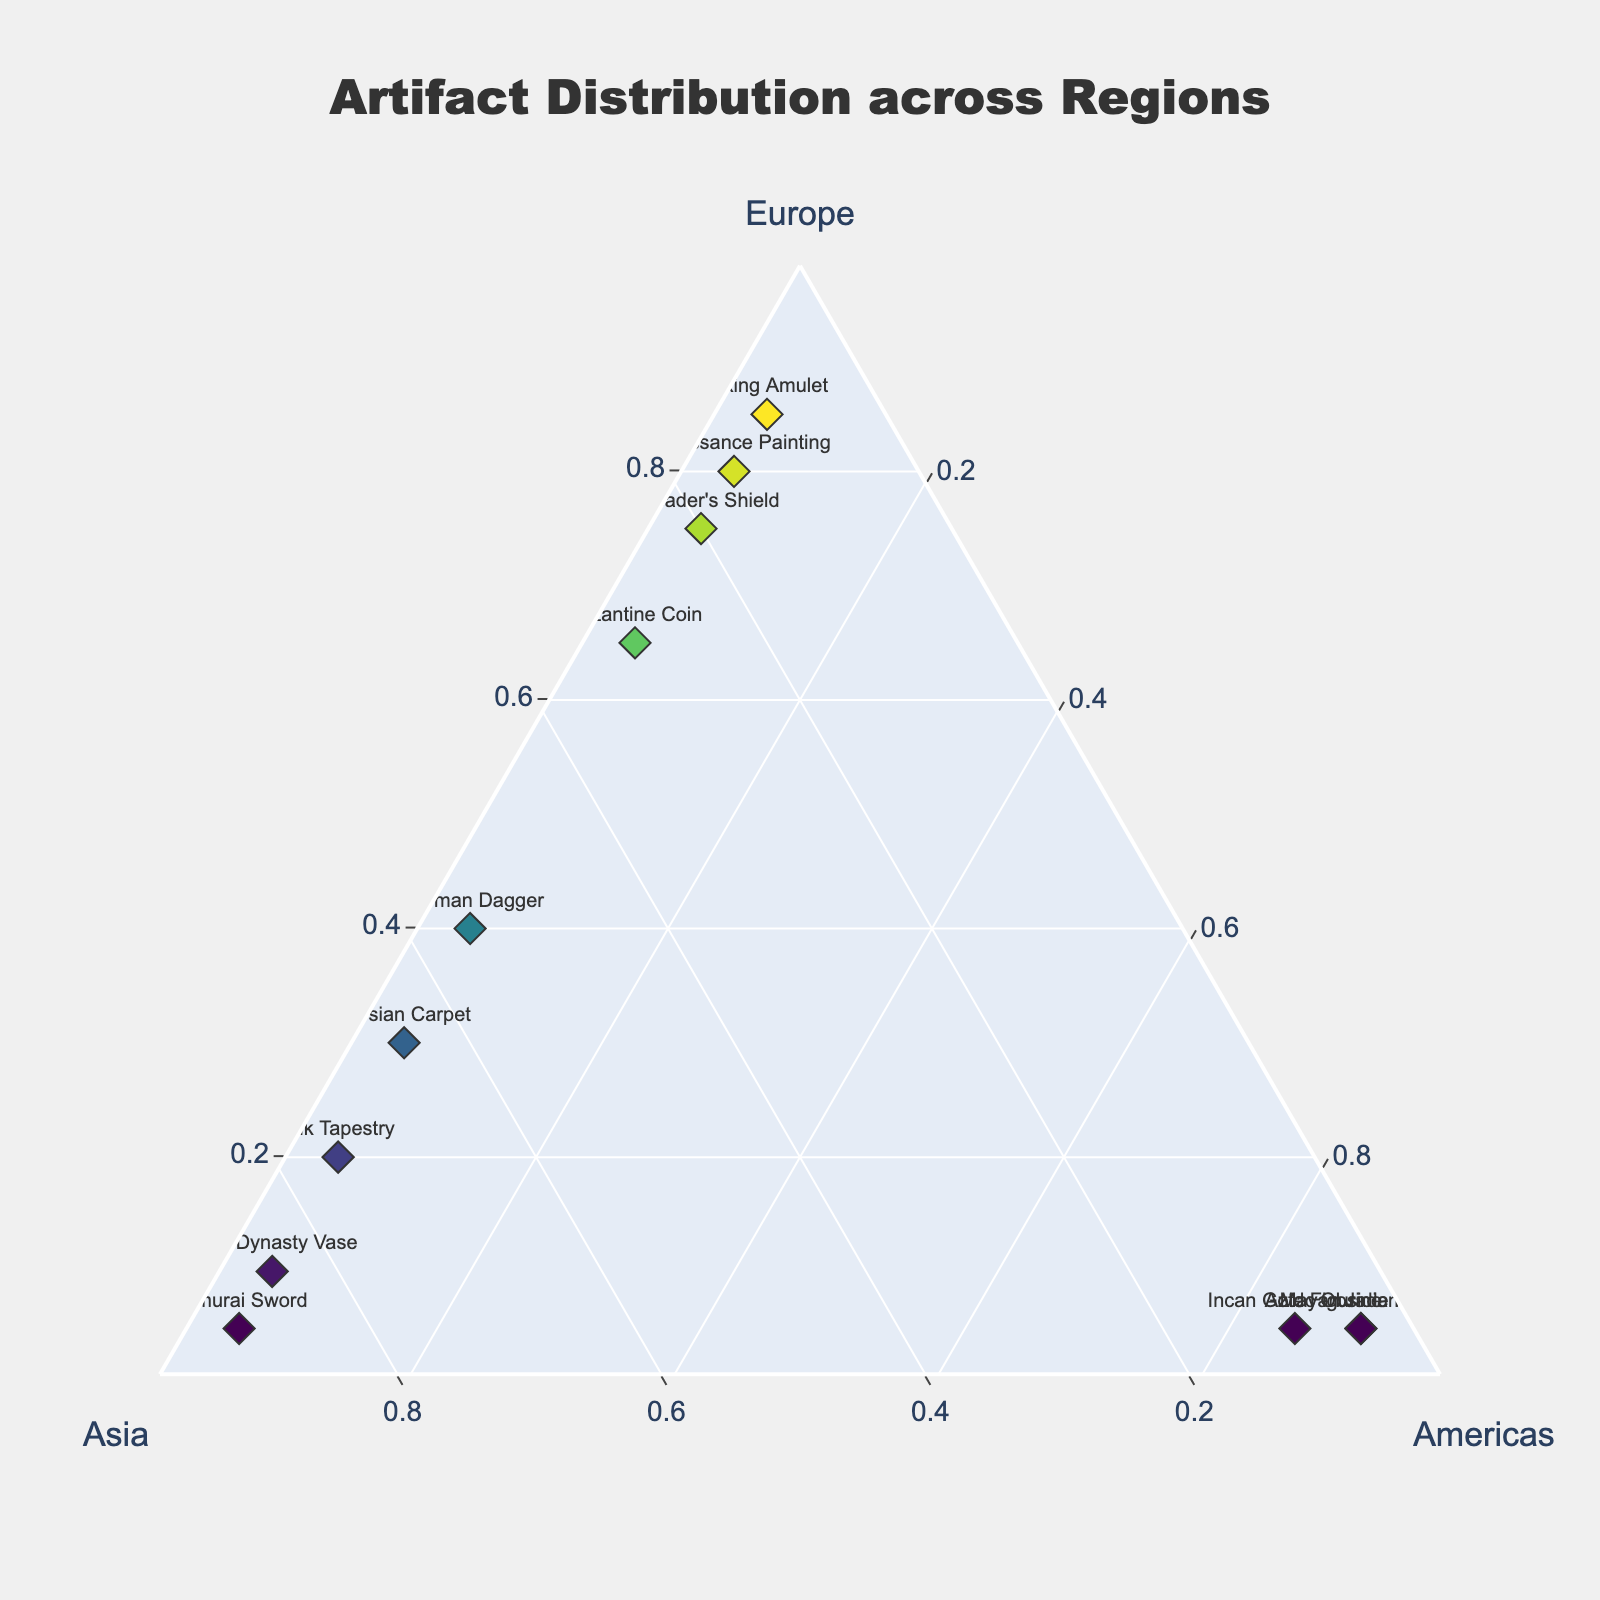What is the title of the figure? The title is displayed at the top center of the figure.
Answer: Artifact Distribution across Regions Which artifact has the highest relative frequency in Europe? The point on the ternary plot closest to the 'Europe' axis with the highest 'Europe' value is the "Viking Amulet" at 0.85.
Answer: Viking Amulet Which artifact has the lowest relative frequency in the Americas? The points with the lowest values at the 'Americas' vertex are all those with 0.05. They are "Byzantine Coin," "Silk Tapestry," "Viking Amulet," "Ming Dynasty Vase," "Renaissance Painting," "Samurai Sword," "Crusader's Shield," and "Persian Carpet."
Answer: Byzantine Coin, Silk Tapestry, Viking Amulet, Ming Dynasty Vase, Renaissance Painting, Samurai Sword, Crusader's Shield, Persian Carpet Which regions have the highest number of artifacts with more than 50% relative frequency? There are the highest number of artifacts in Europe with relative frequencies over 50%: "Byzantine Coin" (0.65), "Viking Amulet" (0.85), "Renaissance Painting" (0.80), and "Crusader's Shield" (0.75). Asia also has several artifacts above 50%: "Silk Tapestry" (0.75), "Ming Dynasty Vase" (0.85), "Samurai Sword" (0.90), and "Persian Carpet" (0.65). The Americas have three: "Incan Gold Figurine" (0.85), "Mayan Jade Mask" (0.90), "Aztec Obsidian Mirror" (0.90).
Answer: Europe and Asia Which artifact is equally distributed in all three regions? Examining the plot, none of the artifacts lie at points close to being equidistant (around 0.33, 0.33, 0.33) from all three vertices.
Answer: None How does the Byzantine Coin compare in relative frequency between Europe and Asia? The Byzantine Coin has a higher relative frequency in Europe (0.65) compared to Asia (0.30).
Answer: Higher in Europe Which artifact found predominantly in Asia has a minor presence in Europe? The artifact "Samurai Sword" with a high relative frequency in Asia (0.90) and a minor presence in Europe (0.05) fits this description.
Answer: Samurai Sword Considering artifacts in the Americas, which artifact has the second highest relative frequency? In the Americas, the second highest relative frequency sees the "Incan Gold Figurine" at 0.85, following "Mayan Jade Mask" (0.90) and "Aztec Obsidian Mirror" (0.90) respectively.
Answer: Incan Gold Figurine If an artifact is equally mixed but not from the Americas, what could it be? An artifact closely distributed between Europe and Asia but low in the Americas is the "Ottoman Dagger," evenly split across Europe (0.40) and Asia (0.55) but minimal in Americas (0.05).
Answer: Ottoman Dagger 